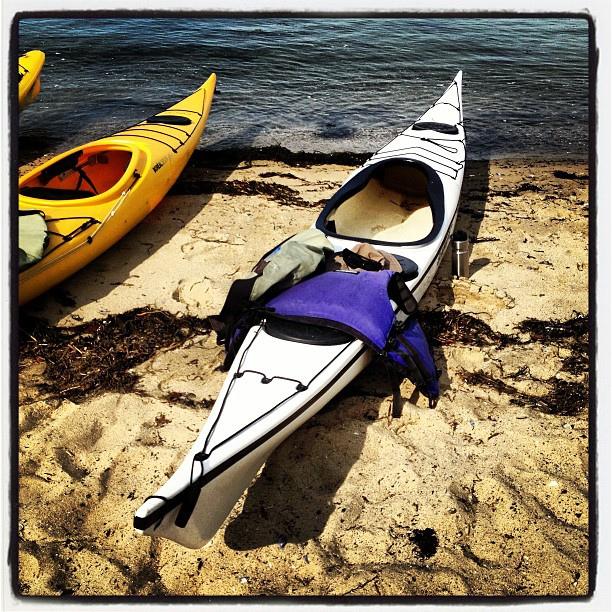Is the water toxic?
Concise answer only. No. What color is the center kayak?
Give a very brief answer. Yellow. Do these have wheels?
Concise answer only. No. 